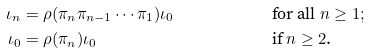Convert formula to latex. <formula><loc_0><loc_0><loc_500><loc_500>& & & & \iota _ { n } & = \rho ( \pi _ { n } \pi _ { n - 1 } \cdots \pi _ { 1 } ) \iota _ { 0 } & & \text {for all $n \geq 1$} ; & & & & \\ & & & & \iota _ { 0 } & = \rho ( \pi _ { n } ) \iota _ { 0 } & & \text {if $n \geq 2$.} & & & &</formula> 